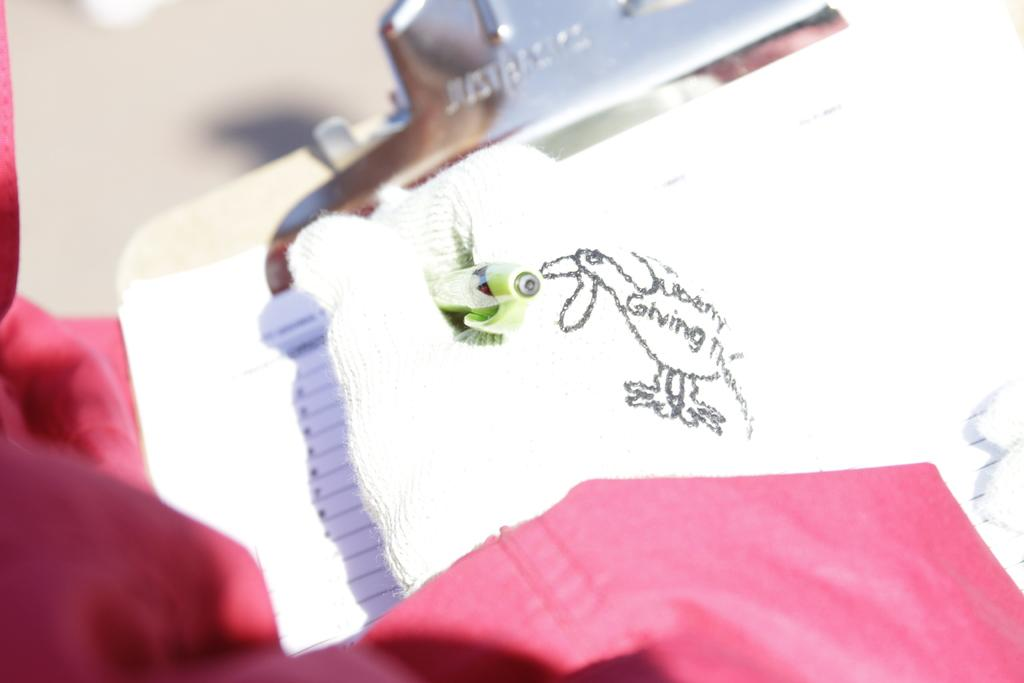What is placed on the pad in the image? There is a paper on a pad in the image. What color is the cloth in the image? The cloth in the image is red. What type of toy can be seen playing with the paper in the image? There is no toy present in the image, and therefore no such activity can be observed. 